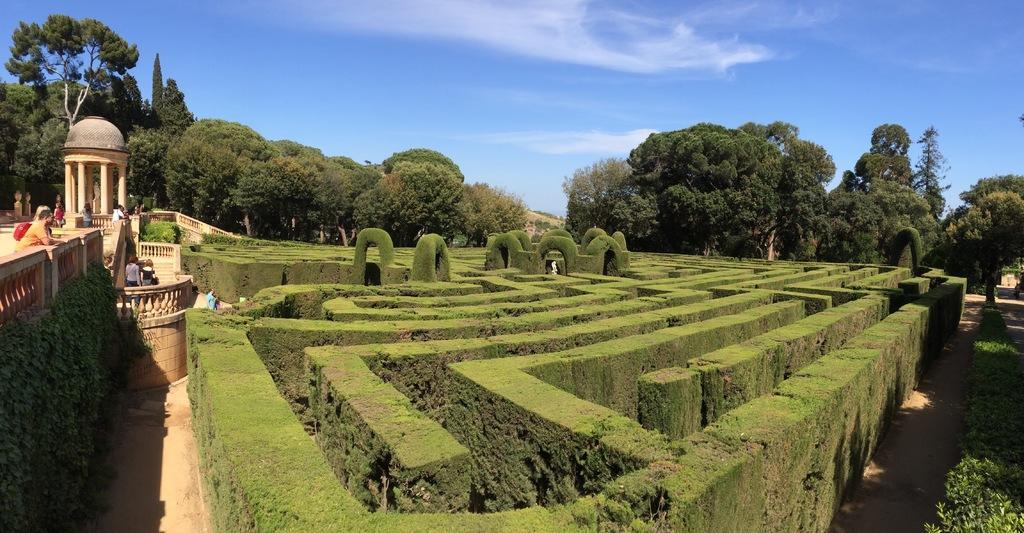In one or two sentences, can you explain what this image depicts? In the center of the image we can see a garden maze. In the background of the image trees are present. On the left side of the image some persons are there. At the top of the image sky is there. At the bottom of the image ground is there. 